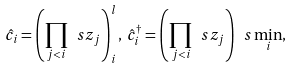Convert formula to latex. <formula><loc_0><loc_0><loc_500><loc_500>\hat { c } _ { i } = \left ( \prod _ { j < i } \ s z _ { j } \right ) ^ { l } _ { i } , \, \hat { c } ^ { \dagger } _ { i } = \left ( \prod _ { j < i } \ s z _ { j } \right ) \ s \min _ { i } ,</formula> 